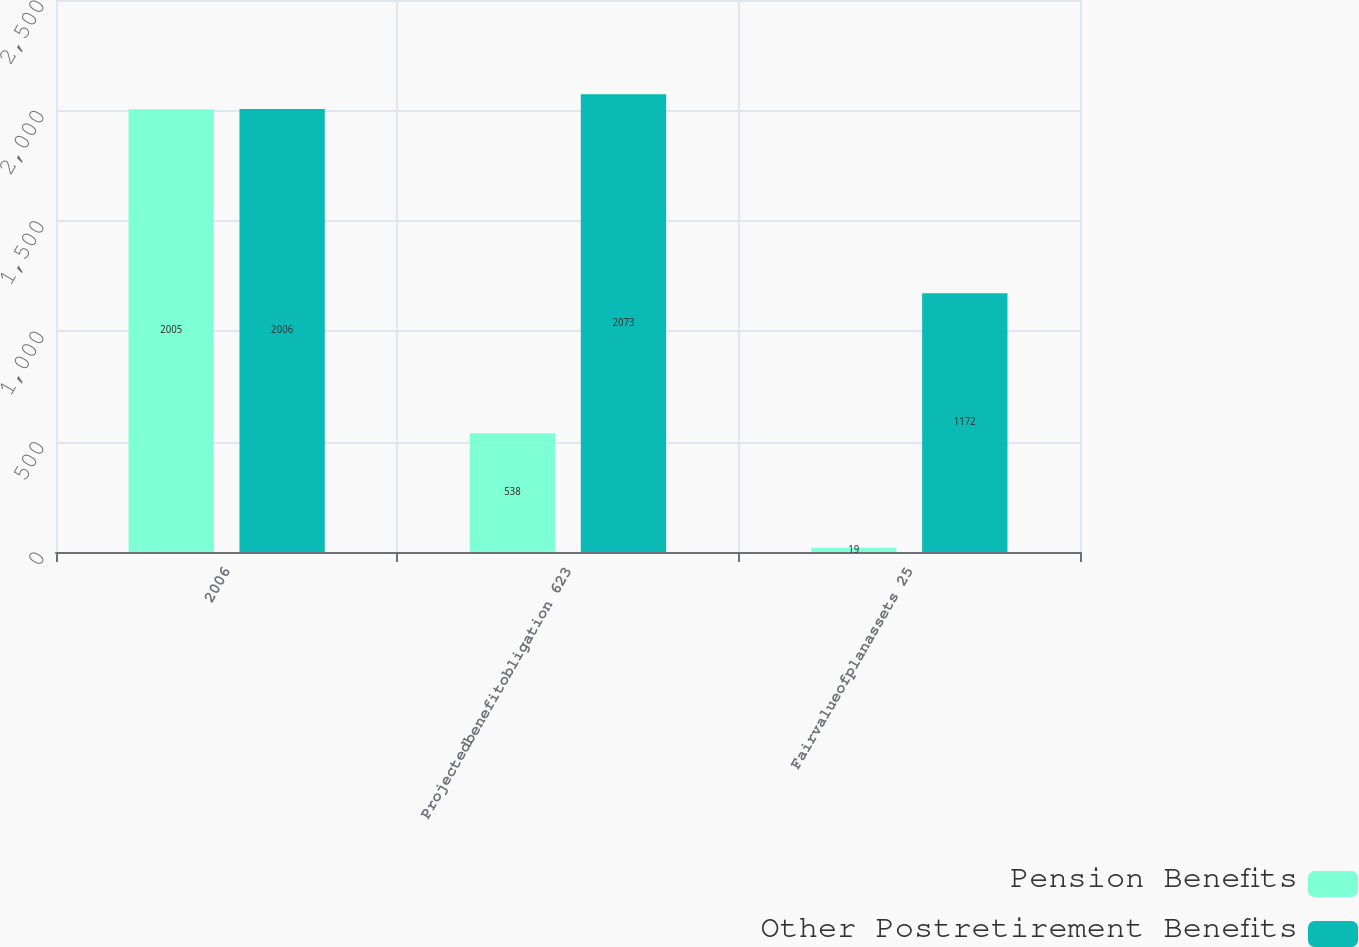Convert chart. <chart><loc_0><loc_0><loc_500><loc_500><stacked_bar_chart><ecel><fcel>2006<fcel>Projectedbenefitobligation 623<fcel>Fairvalueofplanassets 25<nl><fcel>Pension Benefits<fcel>2005<fcel>538<fcel>19<nl><fcel>Other Postretirement Benefits<fcel>2006<fcel>2073<fcel>1172<nl></chart> 